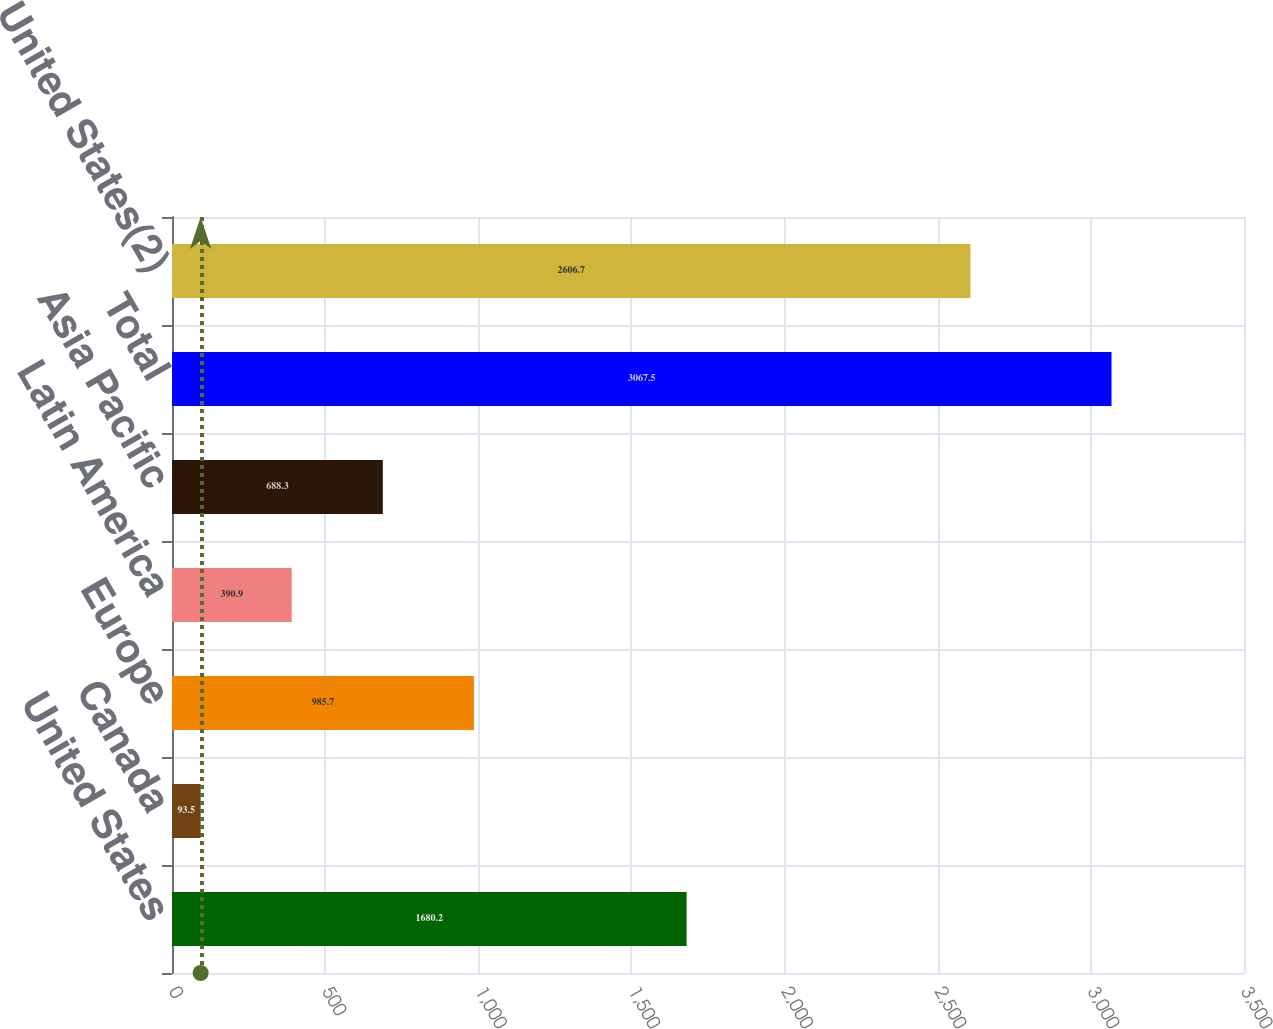<chart> <loc_0><loc_0><loc_500><loc_500><bar_chart><fcel>United States<fcel>Canada<fcel>Europe<fcel>Latin America<fcel>Asia Pacific<fcel>Total<fcel>United States(2)<nl><fcel>1680.2<fcel>93.5<fcel>985.7<fcel>390.9<fcel>688.3<fcel>3067.5<fcel>2606.7<nl></chart> 